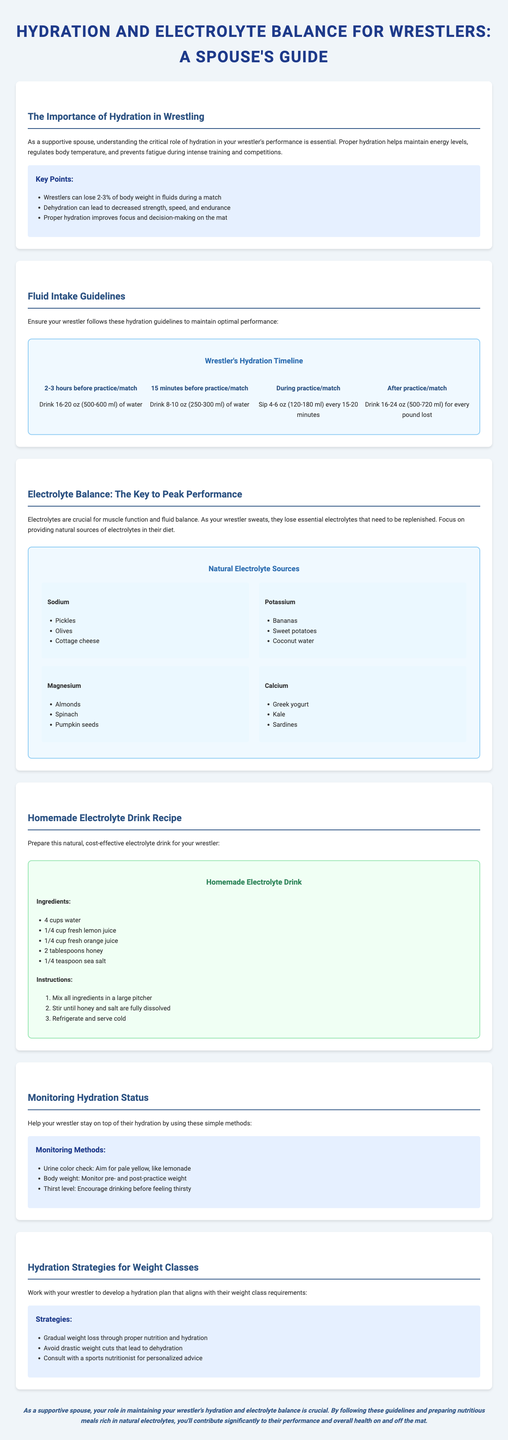What is the title of the brochure? The title of the brochure is provided in the header section.
Answer: Hydration and Electrolyte Balance for Wrestlers: A Spouse's Guide How much water should a wrestler drink 15 minutes before a match? The infographic in the document specifies the amount for this timing.
Answer: Drink 8-10 oz (250-300 ml) of water What is a natural source of potassium? The document lists examples of natural electrolyte sources, specifically for potassium.
Answer: Bananas What should the urine color aim for to indicate proper hydration? The section on monitoring hydration status specifies the ideal urine color.
Answer: Pale yellow What strategy is recommended for preventing dehydration during weight loss? The strategies section highlights key approaches for hydration in weight classes.
Answer: Gradual weight loss through proper nutrition and hydration How many tablespoons of honey are needed for the homemade electrolyte drink? The recipe provides specific quantities for each ingredient used in the drink.
Answer: 2 tablespoons What is the conclusion of the document? The conclusion summarizes the crucial role of the spouse in the wrestler's hydration and electrolyte balance.
Answer: As a supportive spouse, your role in maintaining your wrestler's hydration and electrolyte balance is crucial How often should a wrestler sip water during practice? The section on fluid intake guidelines outlines this recommendation.
Answer: Every 15-20 minutes What is a method to monitor hydration status? The document provides methods for monitoring hydration, asking for specific metrics.
Answer: Urine color check 